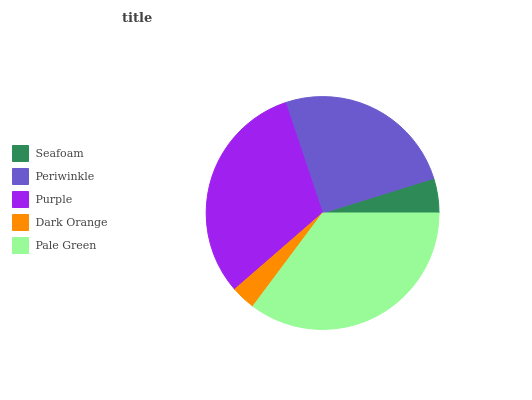Is Dark Orange the minimum?
Answer yes or no. Yes. Is Pale Green the maximum?
Answer yes or no. Yes. Is Periwinkle the minimum?
Answer yes or no. No. Is Periwinkle the maximum?
Answer yes or no. No. Is Periwinkle greater than Seafoam?
Answer yes or no. Yes. Is Seafoam less than Periwinkle?
Answer yes or no. Yes. Is Seafoam greater than Periwinkle?
Answer yes or no. No. Is Periwinkle less than Seafoam?
Answer yes or no. No. Is Periwinkle the high median?
Answer yes or no. Yes. Is Periwinkle the low median?
Answer yes or no. Yes. Is Dark Orange the high median?
Answer yes or no. No. Is Pale Green the low median?
Answer yes or no. No. 